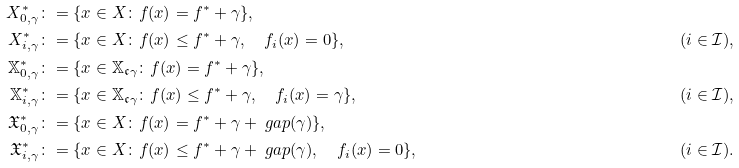Convert formula to latex. <formula><loc_0><loc_0><loc_500><loc_500>X _ { 0 , \gamma } ^ { * } & \colon = \{ x \in X \colon f ( x ) = f ^ { * } + \gamma \} , & \\ X _ { i , \gamma } ^ { * } & \colon = \{ x \in X \colon f ( x ) \leq f ^ { * } + \gamma , \quad f _ { i } ( x ) = 0 \} , & ( i \in \mathcal { I } ) , \\ \mathbb { X } _ { 0 , \gamma } ^ { * } & \colon = \{ x \in \mathbb { X } _ { \mathfrak { c } \gamma } \colon f ( x ) = f ^ { * } + \gamma \} , \\ \mathbb { X } _ { i , \gamma } ^ { * } & \colon = \{ x \in \mathbb { X } _ { \mathfrak { c } \gamma } \colon f ( x ) \leq f ^ { * } + \gamma , \quad f _ { i } ( x ) = \gamma \} , & ( i \in \mathcal { I } ) , \\ \mathfrak { X } _ { 0 , \gamma } ^ { * } & \colon = \{ x \in X \colon f ( x ) = f ^ { * } + \gamma + \ g a p ( \gamma ) \} , & \\ \mathfrak { X } _ { i , \gamma } ^ { * } & \colon = \{ x \in X \colon f ( x ) \leq f ^ { * } + \gamma + \ g a p ( \gamma ) , \quad f _ { i } ( x ) = 0 \} , & ( i \in \mathcal { I } ) .</formula> 